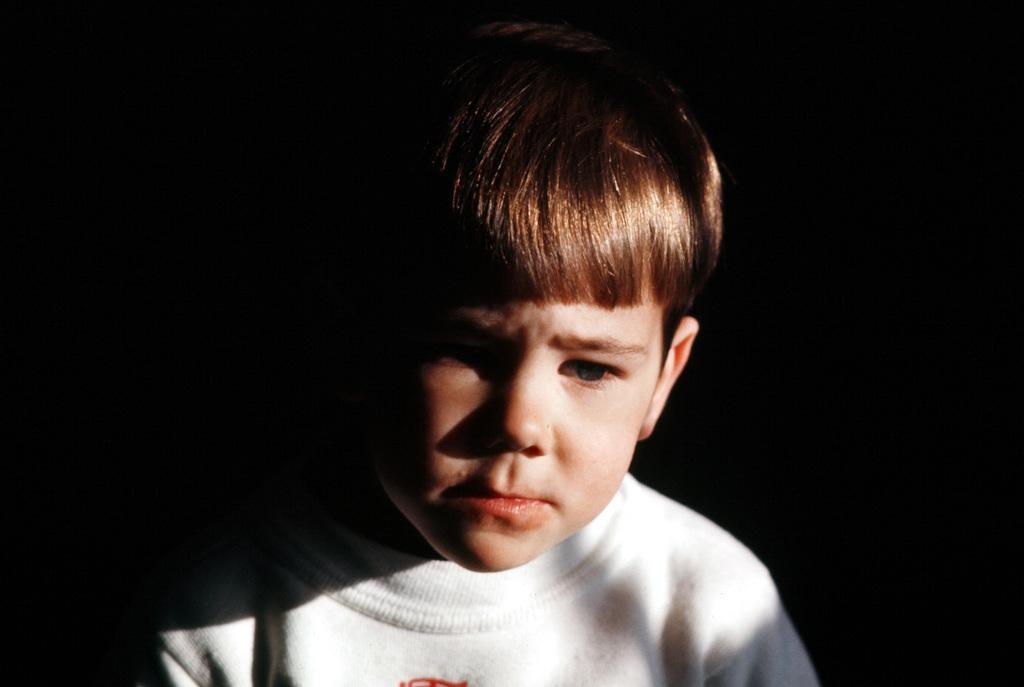Can you describe this image briefly? In this image, I can see a boy with a white T-shirt. The background looks dark. 